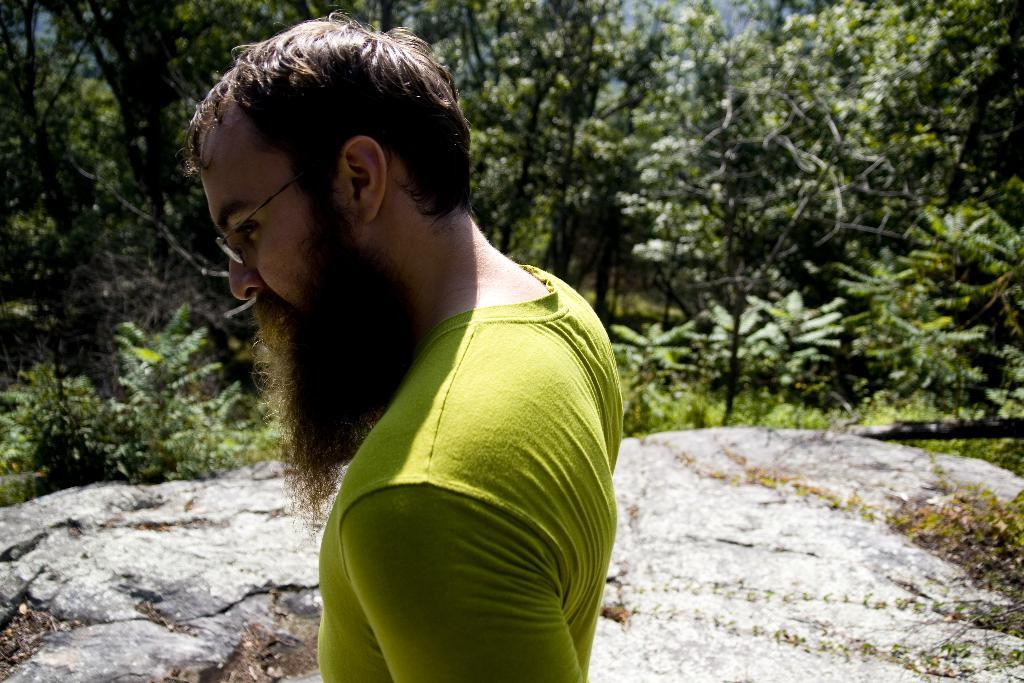Who is the main subject in the picture? There is a man in the middle of the picture. What is the man wearing in the image? The man is wearing a green color T-shirt. What can be seen in the background of the picture? There are trees in the background of the picture. How many noses can be seen in the picture? There is only one person in the picture, and he has one nose. What is the man's birth date in the image? The image does not provide any information about the man's birth date. 